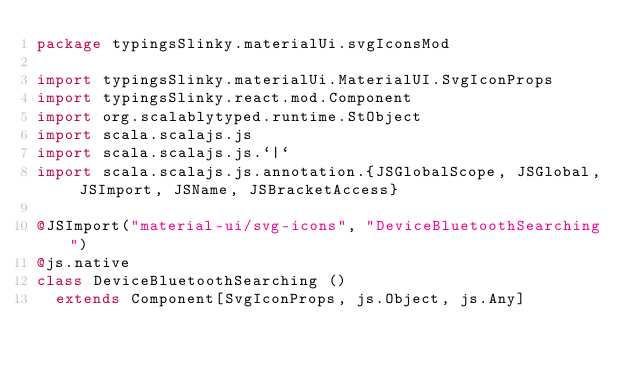Convert code to text. <code><loc_0><loc_0><loc_500><loc_500><_Scala_>package typingsSlinky.materialUi.svgIconsMod

import typingsSlinky.materialUi.MaterialUI.SvgIconProps
import typingsSlinky.react.mod.Component
import org.scalablytyped.runtime.StObject
import scala.scalajs.js
import scala.scalajs.js.`|`
import scala.scalajs.js.annotation.{JSGlobalScope, JSGlobal, JSImport, JSName, JSBracketAccess}

@JSImport("material-ui/svg-icons", "DeviceBluetoothSearching")
@js.native
class DeviceBluetoothSearching ()
  extends Component[SvgIconProps, js.Object, js.Any]
</code> 